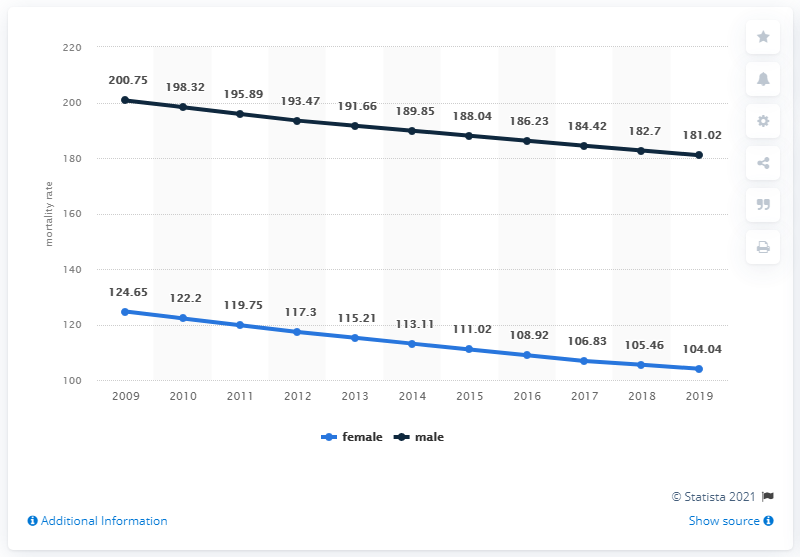Mention a couple of crucial points in this snapshot. The mortality rate for men in Egypt in 2019 was 181.02 per 1,000 people. The female adult mortality rate in 2016 was 108.92 deaths per 1,000 adults. The average of the highest female mortality and the lowest male mortality is 152.835. 